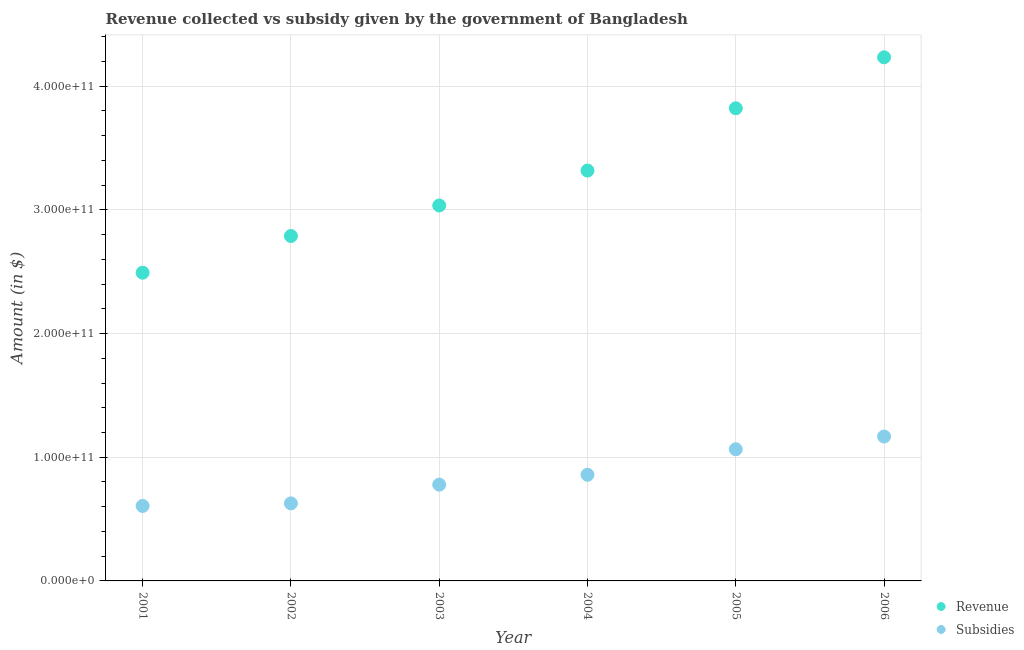How many different coloured dotlines are there?
Your answer should be very brief. 2. Is the number of dotlines equal to the number of legend labels?
Your answer should be compact. Yes. What is the amount of revenue collected in 2002?
Provide a succinct answer. 2.79e+11. Across all years, what is the maximum amount of subsidies given?
Offer a terse response. 1.17e+11. Across all years, what is the minimum amount of subsidies given?
Your response must be concise. 6.06e+1. In which year was the amount of revenue collected minimum?
Ensure brevity in your answer.  2001. What is the total amount of revenue collected in the graph?
Keep it short and to the point. 1.97e+12. What is the difference between the amount of subsidies given in 2001 and that in 2002?
Ensure brevity in your answer.  -2.07e+09. What is the difference between the amount of subsidies given in 2006 and the amount of revenue collected in 2002?
Offer a terse response. -1.62e+11. What is the average amount of subsidies given per year?
Offer a terse response. 8.50e+1. In the year 2002, what is the difference between the amount of subsidies given and amount of revenue collected?
Your answer should be compact. -2.16e+11. In how many years, is the amount of subsidies given greater than 280000000000 $?
Make the answer very short. 0. What is the ratio of the amount of revenue collected in 2001 to that in 2004?
Your answer should be compact. 0.75. What is the difference between the highest and the second highest amount of revenue collected?
Keep it short and to the point. 4.12e+1. What is the difference between the highest and the lowest amount of subsidies given?
Ensure brevity in your answer.  5.61e+1. In how many years, is the amount of subsidies given greater than the average amount of subsidies given taken over all years?
Provide a short and direct response. 3. Is the sum of the amount of subsidies given in 2001 and 2003 greater than the maximum amount of revenue collected across all years?
Provide a short and direct response. No. Is the amount of revenue collected strictly less than the amount of subsidies given over the years?
Keep it short and to the point. No. How many years are there in the graph?
Keep it short and to the point. 6. What is the difference between two consecutive major ticks on the Y-axis?
Give a very brief answer. 1.00e+11. Does the graph contain any zero values?
Offer a terse response. No. How are the legend labels stacked?
Your answer should be compact. Vertical. What is the title of the graph?
Give a very brief answer. Revenue collected vs subsidy given by the government of Bangladesh. Does "Girls" appear as one of the legend labels in the graph?
Ensure brevity in your answer.  No. What is the label or title of the X-axis?
Make the answer very short. Year. What is the label or title of the Y-axis?
Offer a very short reply. Amount (in $). What is the Amount (in $) in Revenue in 2001?
Make the answer very short. 2.49e+11. What is the Amount (in $) of Subsidies in 2001?
Give a very brief answer. 6.06e+1. What is the Amount (in $) of Revenue in 2002?
Provide a short and direct response. 2.79e+11. What is the Amount (in $) of Subsidies in 2002?
Offer a very short reply. 6.27e+1. What is the Amount (in $) of Revenue in 2003?
Ensure brevity in your answer.  3.04e+11. What is the Amount (in $) in Subsidies in 2003?
Your answer should be compact. 7.79e+1. What is the Amount (in $) in Revenue in 2004?
Your answer should be compact. 3.32e+11. What is the Amount (in $) of Subsidies in 2004?
Ensure brevity in your answer.  8.59e+1. What is the Amount (in $) in Revenue in 2005?
Offer a very short reply. 3.82e+11. What is the Amount (in $) in Subsidies in 2005?
Offer a terse response. 1.06e+11. What is the Amount (in $) of Revenue in 2006?
Provide a succinct answer. 4.23e+11. What is the Amount (in $) of Subsidies in 2006?
Provide a succinct answer. 1.17e+11. Across all years, what is the maximum Amount (in $) of Revenue?
Offer a very short reply. 4.23e+11. Across all years, what is the maximum Amount (in $) in Subsidies?
Offer a terse response. 1.17e+11. Across all years, what is the minimum Amount (in $) in Revenue?
Keep it short and to the point. 2.49e+11. Across all years, what is the minimum Amount (in $) of Subsidies?
Ensure brevity in your answer.  6.06e+1. What is the total Amount (in $) in Revenue in the graph?
Make the answer very short. 1.97e+12. What is the total Amount (in $) in Subsidies in the graph?
Provide a succinct answer. 5.10e+11. What is the difference between the Amount (in $) of Revenue in 2001 and that in 2002?
Give a very brief answer. -2.97e+1. What is the difference between the Amount (in $) in Subsidies in 2001 and that in 2002?
Give a very brief answer. -2.07e+09. What is the difference between the Amount (in $) in Revenue in 2001 and that in 2003?
Keep it short and to the point. -5.43e+1. What is the difference between the Amount (in $) of Subsidies in 2001 and that in 2003?
Ensure brevity in your answer.  -1.73e+1. What is the difference between the Amount (in $) of Revenue in 2001 and that in 2004?
Your answer should be compact. -8.26e+1. What is the difference between the Amount (in $) in Subsidies in 2001 and that in 2004?
Your answer should be compact. -2.52e+1. What is the difference between the Amount (in $) in Revenue in 2001 and that in 2005?
Your answer should be very brief. -1.33e+11. What is the difference between the Amount (in $) in Subsidies in 2001 and that in 2005?
Your answer should be very brief. -4.58e+1. What is the difference between the Amount (in $) in Revenue in 2001 and that in 2006?
Offer a terse response. -1.74e+11. What is the difference between the Amount (in $) in Subsidies in 2001 and that in 2006?
Provide a short and direct response. -5.61e+1. What is the difference between the Amount (in $) in Revenue in 2002 and that in 2003?
Your response must be concise. -2.47e+1. What is the difference between the Amount (in $) of Subsidies in 2002 and that in 2003?
Your answer should be very brief. -1.52e+1. What is the difference between the Amount (in $) of Revenue in 2002 and that in 2004?
Your answer should be very brief. -5.29e+1. What is the difference between the Amount (in $) in Subsidies in 2002 and that in 2004?
Your response must be concise. -2.32e+1. What is the difference between the Amount (in $) in Revenue in 2002 and that in 2005?
Ensure brevity in your answer.  -1.03e+11. What is the difference between the Amount (in $) of Subsidies in 2002 and that in 2005?
Offer a very short reply. -4.38e+1. What is the difference between the Amount (in $) of Revenue in 2002 and that in 2006?
Offer a very short reply. -1.45e+11. What is the difference between the Amount (in $) in Subsidies in 2002 and that in 2006?
Offer a terse response. -5.41e+1. What is the difference between the Amount (in $) in Revenue in 2003 and that in 2004?
Your answer should be very brief. -2.82e+1. What is the difference between the Amount (in $) in Subsidies in 2003 and that in 2004?
Give a very brief answer. -7.98e+09. What is the difference between the Amount (in $) of Revenue in 2003 and that in 2005?
Offer a terse response. -7.86e+1. What is the difference between the Amount (in $) of Subsidies in 2003 and that in 2005?
Keep it short and to the point. -2.86e+1. What is the difference between the Amount (in $) in Revenue in 2003 and that in 2006?
Your answer should be very brief. -1.20e+11. What is the difference between the Amount (in $) of Subsidies in 2003 and that in 2006?
Ensure brevity in your answer.  -3.89e+1. What is the difference between the Amount (in $) of Revenue in 2004 and that in 2005?
Offer a very short reply. -5.04e+1. What is the difference between the Amount (in $) of Subsidies in 2004 and that in 2005?
Offer a terse response. -2.06e+1. What is the difference between the Amount (in $) of Revenue in 2004 and that in 2006?
Give a very brief answer. -9.16e+1. What is the difference between the Amount (in $) of Subsidies in 2004 and that in 2006?
Give a very brief answer. -3.09e+1. What is the difference between the Amount (in $) in Revenue in 2005 and that in 2006?
Provide a succinct answer. -4.12e+1. What is the difference between the Amount (in $) of Subsidies in 2005 and that in 2006?
Offer a very short reply. -1.03e+1. What is the difference between the Amount (in $) in Revenue in 2001 and the Amount (in $) in Subsidies in 2002?
Offer a terse response. 1.87e+11. What is the difference between the Amount (in $) in Revenue in 2001 and the Amount (in $) in Subsidies in 2003?
Provide a succinct answer. 1.71e+11. What is the difference between the Amount (in $) in Revenue in 2001 and the Amount (in $) in Subsidies in 2004?
Provide a short and direct response. 1.63e+11. What is the difference between the Amount (in $) in Revenue in 2001 and the Amount (in $) in Subsidies in 2005?
Make the answer very short. 1.43e+11. What is the difference between the Amount (in $) of Revenue in 2001 and the Amount (in $) of Subsidies in 2006?
Your answer should be compact. 1.32e+11. What is the difference between the Amount (in $) of Revenue in 2002 and the Amount (in $) of Subsidies in 2003?
Keep it short and to the point. 2.01e+11. What is the difference between the Amount (in $) in Revenue in 2002 and the Amount (in $) in Subsidies in 2004?
Your answer should be very brief. 1.93e+11. What is the difference between the Amount (in $) in Revenue in 2002 and the Amount (in $) in Subsidies in 2005?
Keep it short and to the point. 1.72e+11. What is the difference between the Amount (in $) of Revenue in 2002 and the Amount (in $) of Subsidies in 2006?
Your answer should be compact. 1.62e+11. What is the difference between the Amount (in $) in Revenue in 2003 and the Amount (in $) in Subsidies in 2004?
Your answer should be compact. 2.18e+11. What is the difference between the Amount (in $) of Revenue in 2003 and the Amount (in $) of Subsidies in 2005?
Make the answer very short. 1.97e+11. What is the difference between the Amount (in $) of Revenue in 2003 and the Amount (in $) of Subsidies in 2006?
Offer a very short reply. 1.87e+11. What is the difference between the Amount (in $) in Revenue in 2004 and the Amount (in $) in Subsidies in 2005?
Provide a succinct answer. 2.25e+11. What is the difference between the Amount (in $) in Revenue in 2004 and the Amount (in $) in Subsidies in 2006?
Your response must be concise. 2.15e+11. What is the difference between the Amount (in $) of Revenue in 2005 and the Amount (in $) of Subsidies in 2006?
Ensure brevity in your answer.  2.65e+11. What is the average Amount (in $) in Revenue per year?
Offer a terse response. 3.28e+11. What is the average Amount (in $) in Subsidies per year?
Ensure brevity in your answer.  8.50e+1. In the year 2001, what is the difference between the Amount (in $) of Revenue and Amount (in $) of Subsidies?
Your answer should be very brief. 1.89e+11. In the year 2002, what is the difference between the Amount (in $) of Revenue and Amount (in $) of Subsidies?
Offer a very short reply. 2.16e+11. In the year 2003, what is the difference between the Amount (in $) of Revenue and Amount (in $) of Subsidies?
Offer a terse response. 2.26e+11. In the year 2004, what is the difference between the Amount (in $) of Revenue and Amount (in $) of Subsidies?
Offer a terse response. 2.46e+11. In the year 2005, what is the difference between the Amount (in $) of Revenue and Amount (in $) of Subsidies?
Your answer should be compact. 2.76e+11. In the year 2006, what is the difference between the Amount (in $) in Revenue and Amount (in $) in Subsidies?
Your answer should be very brief. 3.07e+11. What is the ratio of the Amount (in $) of Revenue in 2001 to that in 2002?
Give a very brief answer. 0.89. What is the ratio of the Amount (in $) of Subsidies in 2001 to that in 2002?
Make the answer very short. 0.97. What is the ratio of the Amount (in $) in Revenue in 2001 to that in 2003?
Keep it short and to the point. 0.82. What is the ratio of the Amount (in $) in Subsidies in 2001 to that in 2003?
Provide a succinct answer. 0.78. What is the ratio of the Amount (in $) in Revenue in 2001 to that in 2004?
Your answer should be compact. 0.75. What is the ratio of the Amount (in $) of Subsidies in 2001 to that in 2004?
Provide a short and direct response. 0.71. What is the ratio of the Amount (in $) in Revenue in 2001 to that in 2005?
Make the answer very short. 0.65. What is the ratio of the Amount (in $) of Subsidies in 2001 to that in 2005?
Your response must be concise. 0.57. What is the ratio of the Amount (in $) of Revenue in 2001 to that in 2006?
Offer a very short reply. 0.59. What is the ratio of the Amount (in $) of Subsidies in 2001 to that in 2006?
Your answer should be compact. 0.52. What is the ratio of the Amount (in $) of Revenue in 2002 to that in 2003?
Offer a very short reply. 0.92. What is the ratio of the Amount (in $) of Subsidies in 2002 to that in 2003?
Provide a short and direct response. 0.81. What is the ratio of the Amount (in $) in Revenue in 2002 to that in 2004?
Make the answer very short. 0.84. What is the ratio of the Amount (in $) in Subsidies in 2002 to that in 2004?
Give a very brief answer. 0.73. What is the ratio of the Amount (in $) of Revenue in 2002 to that in 2005?
Your answer should be compact. 0.73. What is the ratio of the Amount (in $) in Subsidies in 2002 to that in 2005?
Offer a terse response. 0.59. What is the ratio of the Amount (in $) of Revenue in 2002 to that in 2006?
Offer a terse response. 0.66. What is the ratio of the Amount (in $) in Subsidies in 2002 to that in 2006?
Your answer should be compact. 0.54. What is the ratio of the Amount (in $) of Revenue in 2003 to that in 2004?
Make the answer very short. 0.92. What is the ratio of the Amount (in $) of Subsidies in 2003 to that in 2004?
Your answer should be very brief. 0.91. What is the ratio of the Amount (in $) in Revenue in 2003 to that in 2005?
Provide a succinct answer. 0.79. What is the ratio of the Amount (in $) in Subsidies in 2003 to that in 2005?
Offer a very short reply. 0.73. What is the ratio of the Amount (in $) of Revenue in 2003 to that in 2006?
Give a very brief answer. 0.72. What is the ratio of the Amount (in $) in Subsidies in 2003 to that in 2006?
Ensure brevity in your answer.  0.67. What is the ratio of the Amount (in $) in Revenue in 2004 to that in 2005?
Your answer should be compact. 0.87. What is the ratio of the Amount (in $) of Subsidies in 2004 to that in 2005?
Offer a very short reply. 0.81. What is the ratio of the Amount (in $) in Revenue in 2004 to that in 2006?
Provide a succinct answer. 0.78. What is the ratio of the Amount (in $) of Subsidies in 2004 to that in 2006?
Make the answer very short. 0.74. What is the ratio of the Amount (in $) in Revenue in 2005 to that in 2006?
Give a very brief answer. 0.9. What is the ratio of the Amount (in $) of Subsidies in 2005 to that in 2006?
Make the answer very short. 0.91. What is the difference between the highest and the second highest Amount (in $) in Revenue?
Provide a short and direct response. 4.12e+1. What is the difference between the highest and the second highest Amount (in $) of Subsidies?
Make the answer very short. 1.03e+1. What is the difference between the highest and the lowest Amount (in $) in Revenue?
Your answer should be very brief. 1.74e+11. What is the difference between the highest and the lowest Amount (in $) in Subsidies?
Keep it short and to the point. 5.61e+1. 